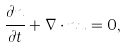Convert formula to latex. <formula><loc_0><loc_0><loc_500><loc_500>\frac { \partial n } { \partial t } + \nabla \cdot n { u } = 0 ,</formula> 